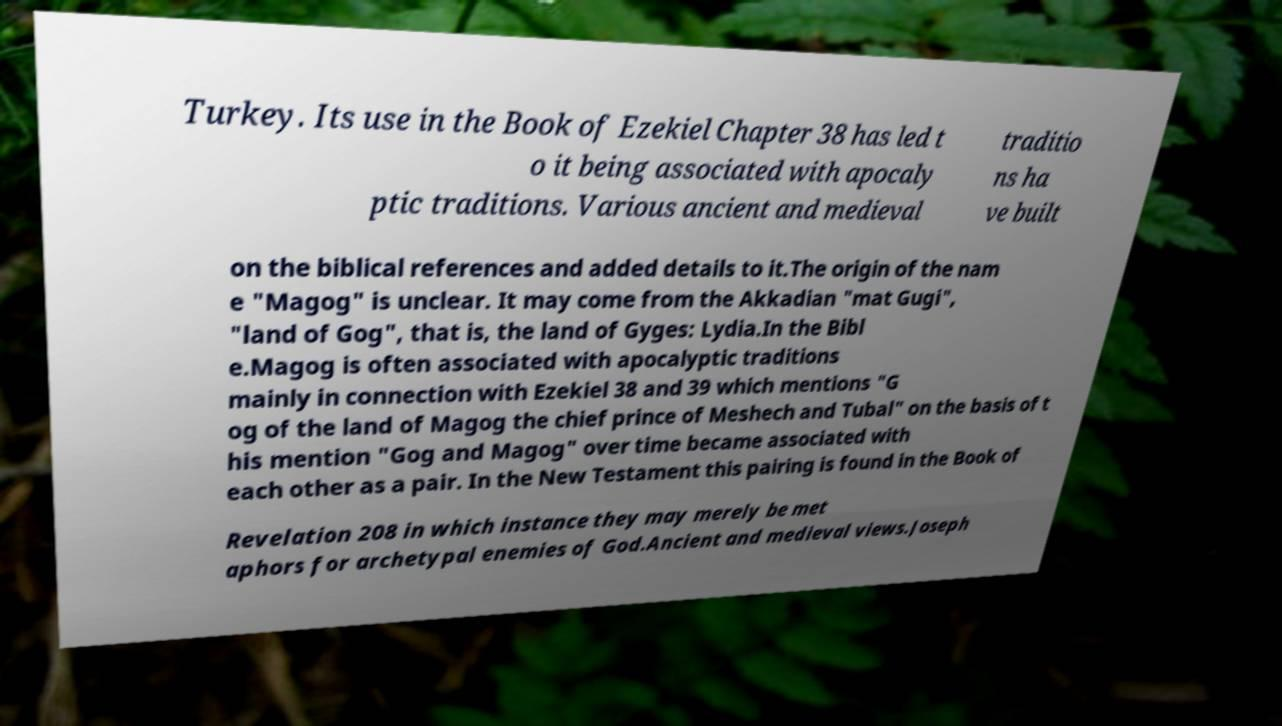What messages or text are displayed in this image? I need them in a readable, typed format. Turkey. Its use in the Book of Ezekiel Chapter 38 has led t o it being associated with apocaly ptic traditions. Various ancient and medieval traditio ns ha ve built on the biblical references and added details to it.The origin of the nam e "Magog" is unclear. It may come from the Akkadian "mat Gugi", "land of Gog", that is, the land of Gyges: Lydia.In the Bibl e.Magog is often associated with apocalyptic traditions mainly in connection with Ezekiel 38 and 39 which mentions "G og of the land of Magog the chief prince of Meshech and Tubal" on the basis of t his mention "Gog and Magog" over time became associated with each other as a pair. In the New Testament this pairing is found in the Book of Revelation 208 in which instance they may merely be met aphors for archetypal enemies of God.Ancient and medieval views.Joseph 